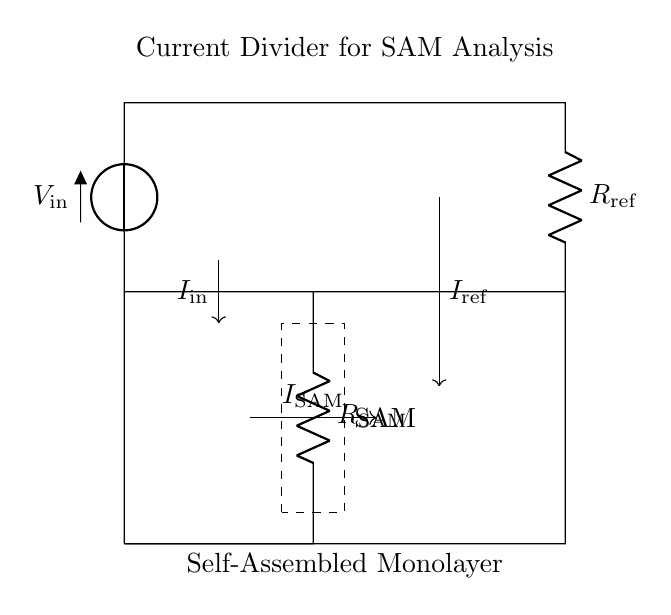What is the input voltage in the circuit? The input voltage is denoted as V_in located at the top of the circuit. It is the voltage source providing power to the rest of the circuit.
Answer: V_in What are the two resistors in the circuit? The two resistors are R_ref and R_SAM, indicated in the circuit. R_ref is in series with the input voltage, while R_SAM is in the branch for the self-assembled monolayer.
Answer: R_ref, R_SAM What is the current flowing through the reference resistor? The current flowing through the reference resistor is indicated as I_ref, shown entering the reference resistor on the right side of the circuit. It is derived from the input current I_in.
Answer: I_ref Which component represents the self-assembled monolayer? The self-assembled monolayer is represented by the dashed rectangle labeled SAM in the circuit diagram. This indicates the location and significance of the SAM in the current flow.
Answer: SAM How does the configuration demonstrate a current divider? The circuit shows a current divider configuration where the input current I_in splits into I_SAM and I_ref, based on the resistive values. This is characterized by the presence of two parallel paths for current.
Answer: Current divider What is the total current entering the circuit? The total current entering the circuit is denoted as I_in, which is the current sourced from the voltage input V_in and is divided between the two resistors.
Answer: I_in How do the resistances affect the current division? The resistances affect the current division according to Ohm's Law; the current is inversely proportional to the resistance values, meaning larger resistance will receive less current. This principle determines how I_SAM and I_ref distribute from I_in.
Answer: By resistance values 